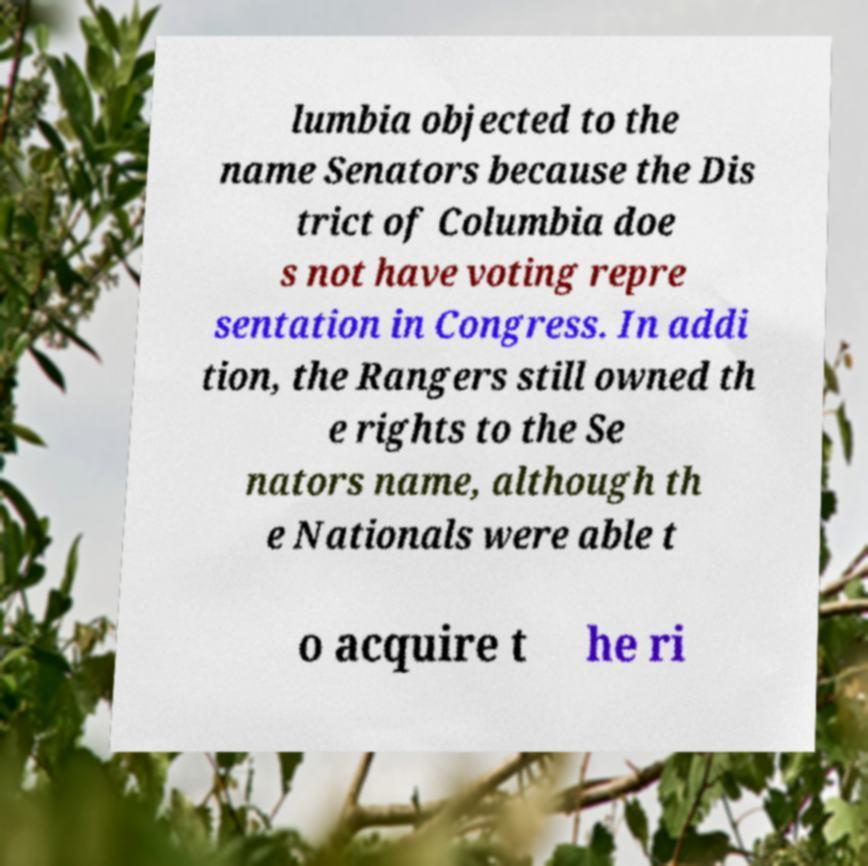Please read and relay the text visible in this image. What does it say? lumbia objected to the name Senators because the Dis trict of Columbia doe s not have voting repre sentation in Congress. In addi tion, the Rangers still owned th e rights to the Se nators name, although th e Nationals were able t o acquire t he ri 